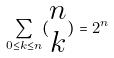<formula> <loc_0><loc_0><loc_500><loc_500>\sum _ { 0 \leq k \leq n } ( \begin{matrix} n \\ k \end{matrix} ) = 2 ^ { n }</formula> 